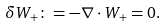<formula> <loc_0><loc_0><loc_500><loc_500>\delta W _ { + } \colon = - \nabla \cdot W _ { + } = 0 .</formula> 